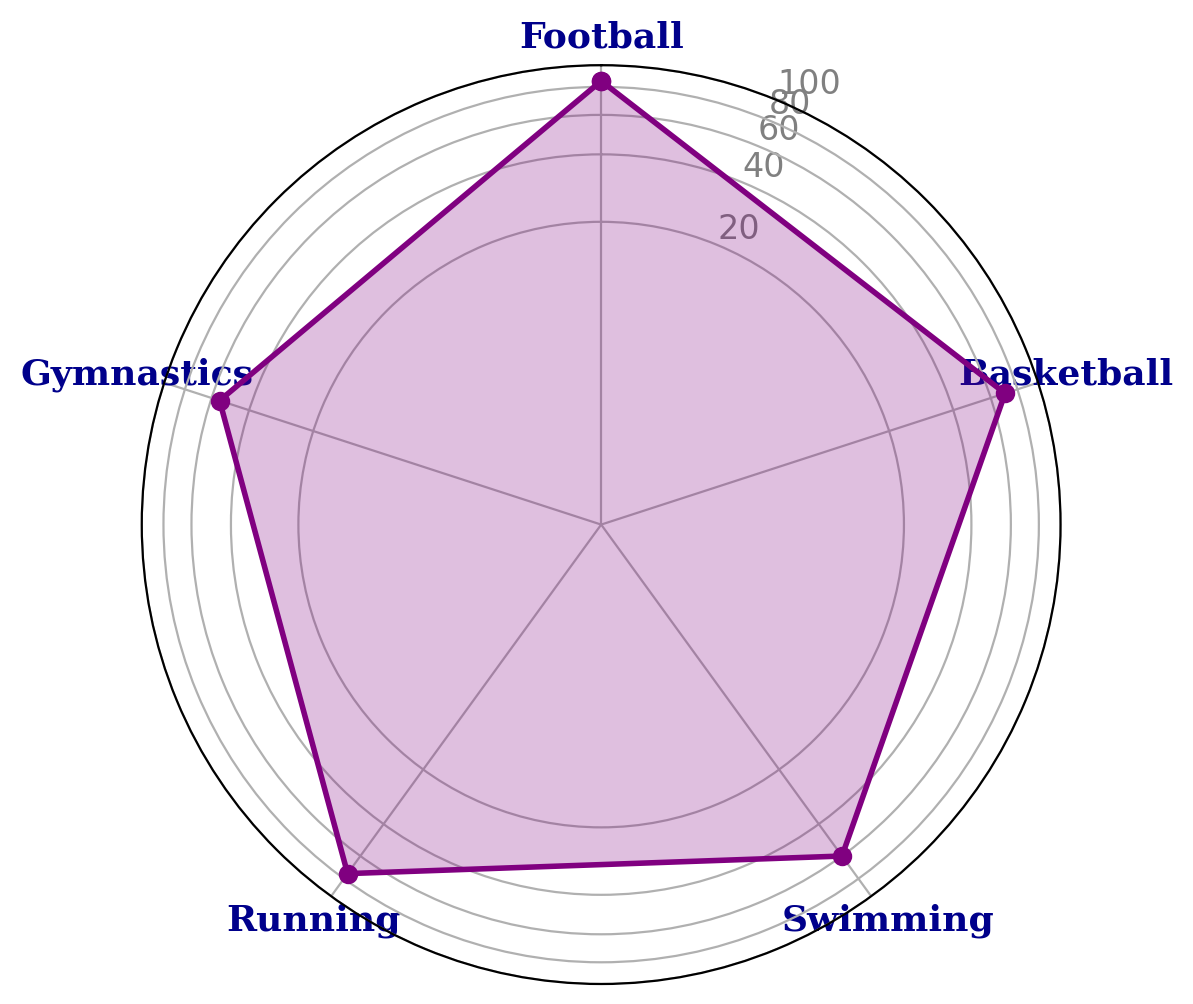Which sport disciplines have an interest level above 65? By looking at the radar chart, you can see that the lines marking 65 are below the labeled dots for Football, Basketball, and Running. Hence, these three sports disciplines have an interest level above 65.
Answer: Football, Basketball, Running Which sport discipline has the lowest mean interest level? Observing the radar chart, the point closest to the center represents the lowest mean interest level. This point is labeled Gymnastics.
Answer: Gymnastics What is the difference in interest levels between Football and Swimming? Football's interest level is 85 while Swimming's is 60. The difference is calculated by subtracting Swimming's level from Football's: 85 - 60 = 25.
Answer: 25 On average, how much more interested are students in Running compared to Gymnastics? Running has an interest level of 75 and Gymnastics has 55. The difference between them is 75 - 55 = 20. To find the average difference: 20 / 2 = 10.
Answer: 10 Which two sport disciplines have the most similar interest levels? By visually comparing the lengths of all the plotted points, the two closest points are Basketball (70) and Running (75). The difference between them is only 5.
Answer: Basketball and Running What is the median interest level of all the sports disciplines? To find the median of the interest levels: (55, 60, 70, 75, 85), the middle value is 70 (Basketball).
Answer: 70 What is the sum of interest levels of all sports disciplines? Adding up all the interest levels: 85 (Football) + 70 (Basketball) + 60 (Swimming) + 75 (Running) + 55 (Gymnastics) = 345.
Answer: 345 How does the mean interest level in Football compare to the mean interest level in Gymnastics? The interest level in Football (85) is much higher compared to that in Gymnastics (55). The difference is 85 - 55 = 30, showing that Football is significantly more popular.
Answer: 30 What is the overall average interest level for all the sports disciplines? Sum the interest levels: 85 + 70 + 60 + 75 + 55 = 345. Divide by the number of disciplines (5): 345 / 5 = 69.
Answer: 69 